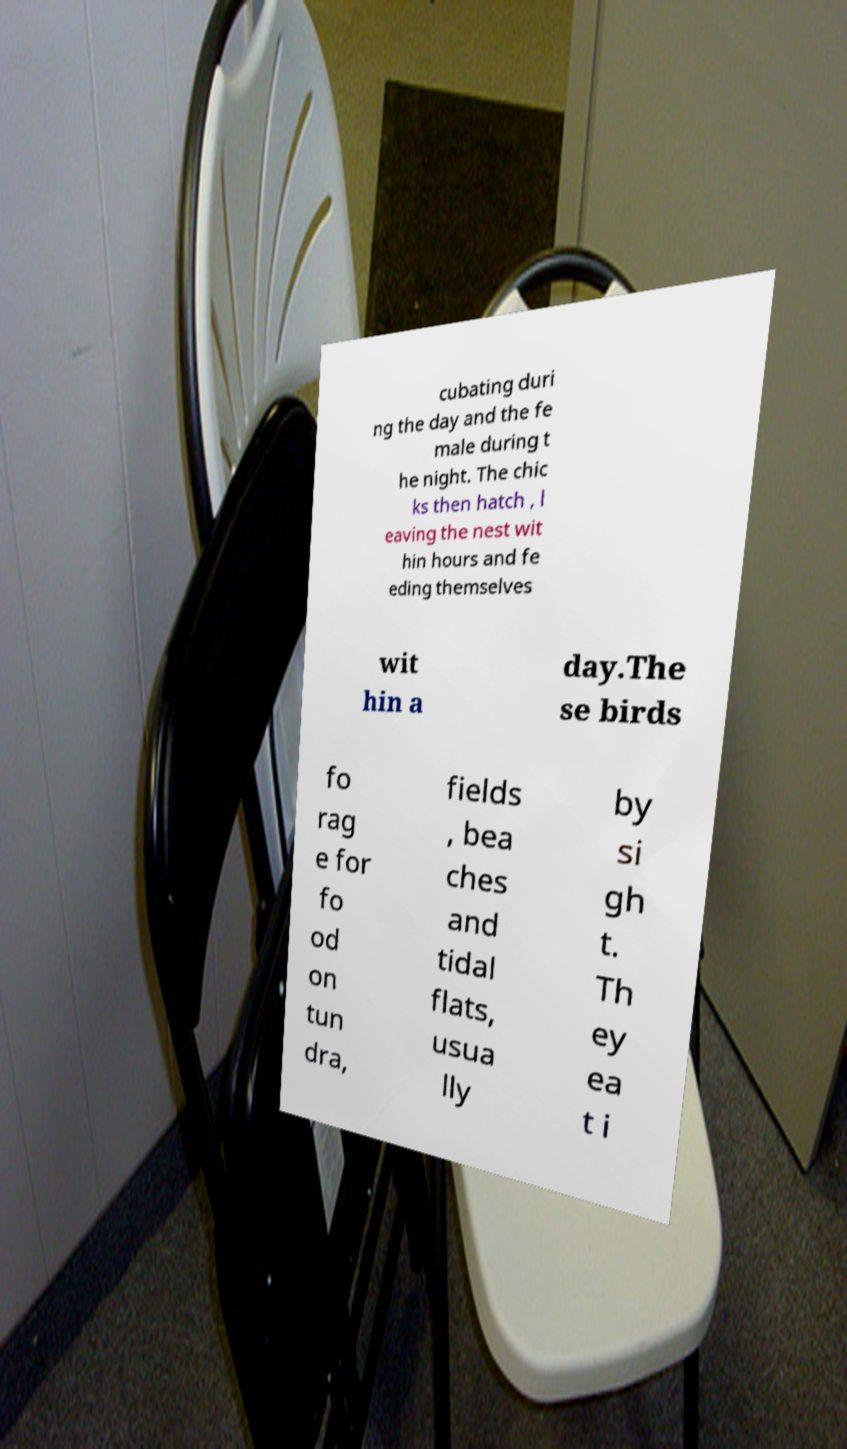Can you read and provide the text displayed in the image?This photo seems to have some interesting text. Can you extract and type it out for me? cubating duri ng the day and the fe male during t he night. The chic ks then hatch , l eaving the nest wit hin hours and fe eding themselves wit hin a day.The se birds fo rag e for fo od on tun dra, fields , bea ches and tidal flats, usua lly by si gh t. Th ey ea t i 